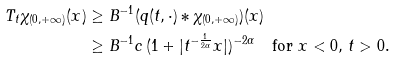Convert formula to latex. <formula><loc_0><loc_0><loc_500><loc_500>T _ { t } \chi _ { ( 0 , + \infty ) } ( x ) & \geq B ^ { - 1 } ( q ( t , \cdot ) \ast \chi _ { ( 0 , + \infty ) } ) ( x ) \\ & \geq B ^ { - 1 } c \, ( 1 + | { t ^ { - \frac { 1 } { 2 \alpha } } } x | ) ^ { - 2 \alpha } \quad \text {for } x < 0 , \, t > 0 .</formula> 